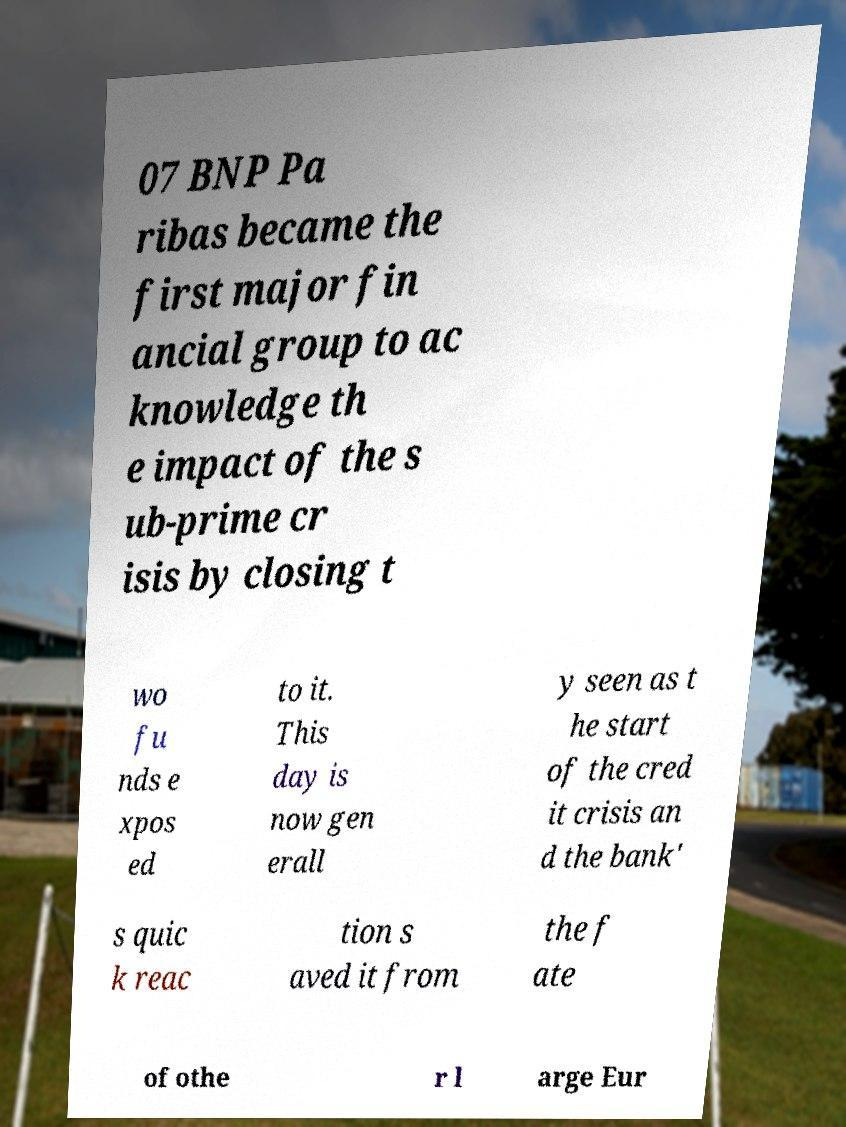Could you extract and type out the text from this image? 07 BNP Pa ribas became the first major fin ancial group to ac knowledge th e impact of the s ub-prime cr isis by closing t wo fu nds e xpos ed to it. This day is now gen erall y seen as t he start of the cred it crisis an d the bank' s quic k reac tion s aved it from the f ate of othe r l arge Eur 